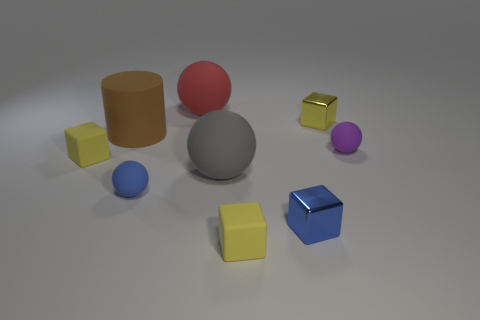Subtract all purple spheres. How many yellow cubes are left? 3 Subtract 1 spheres. How many spheres are left? 3 Subtract all blue cubes. How many cubes are left? 3 Subtract all green cubes. Subtract all red cylinders. How many cubes are left? 4 Add 1 large rubber cylinders. How many objects exist? 10 Subtract all cubes. How many objects are left? 5 Add 6 small blue matte things. How many small blue matte things are left? 7 Add 4 red rubber things. How many red rubber things exist? 5 Subtract 0 purple cylinders. How many objects are left? 9 Subtract all big rubber objects. Subtract all big objects. How many objects are left? 3 